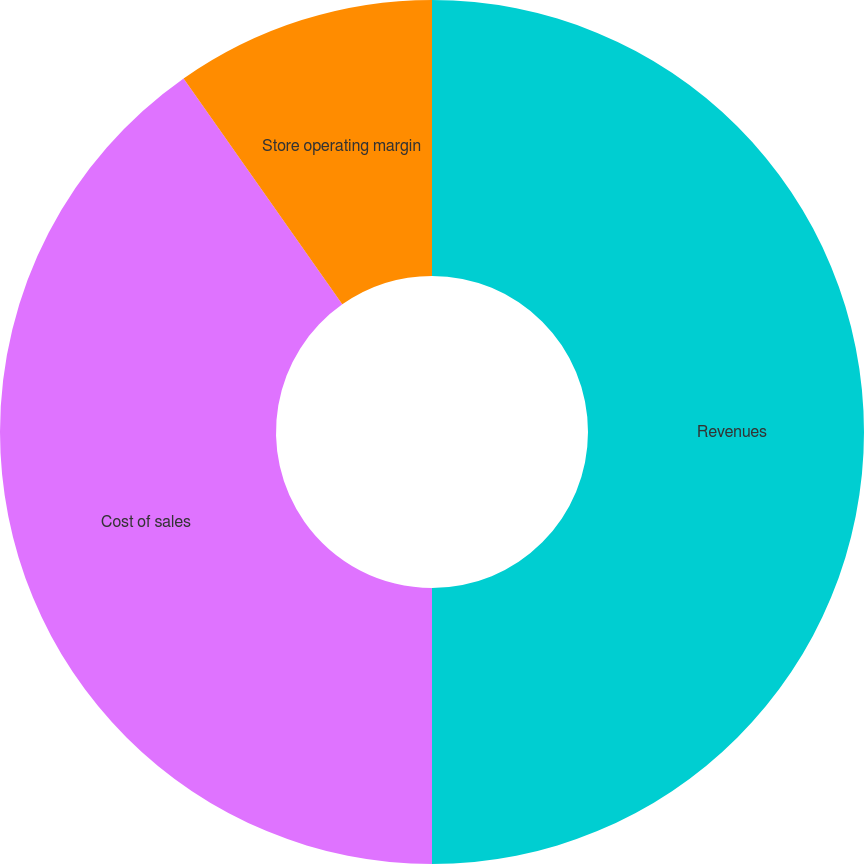Convert chart to OTSL. <chart><loc_0><loc_0><loc_500><loc_500><pie_chart><fcel>Revenues<fcel>Cost of sales<fcel>Store operating margin<nl><fcel>50.0%<fcel>40.25%<fcel>9.75%<nl></chart> 